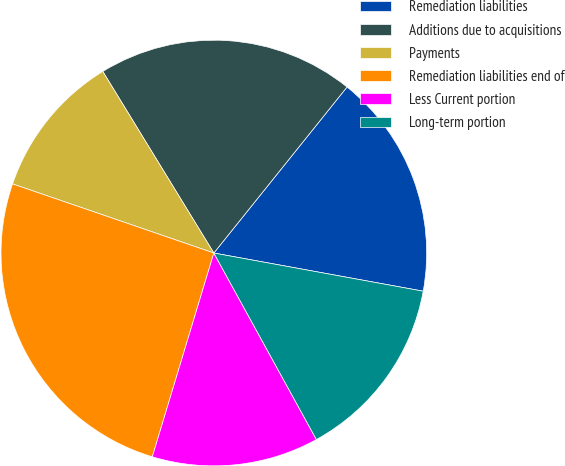<chart> <loc_0><loc_0><loc_500><loc_500><pie_chart><fcel>Remediation liabilities<fcel>Additions due to acquisitions<fcel>Payments<fcel>Remediation liabilities end of<fcel>Less Current portion<fcel>Long-term portion<nl><fcel>17.11%<fcel>19.5%<fcel>11.0%<fcel>25.6%<fcel>12.67%<fcel>14.13%<nl></chart> 